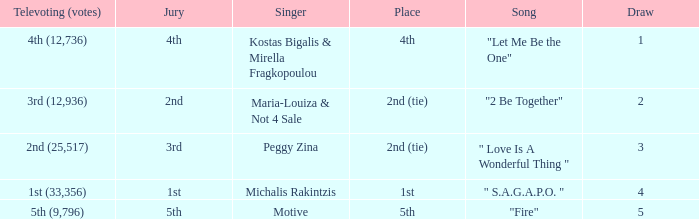What is the greatest draw that has 4th for place? 1.0. 